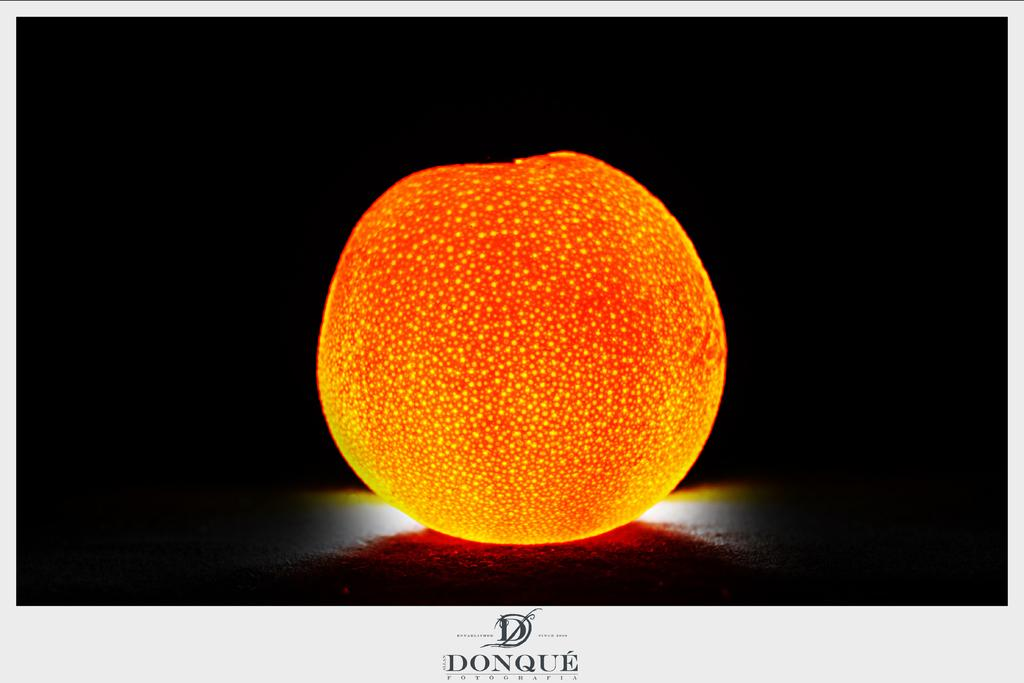What type of image is in the picture? There is a graphical image in the picture. Is there any text associated with the image? Yes, there is text at the bottom of the picture. What can be observed about the overall appearance of the image? The background of the image is dark. How much does the honey weigh in the image? There is no honey present in the image, so it is not possible to determine its weight. 